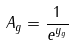<formula> <loc_0><loc_0><loc_500><loc_500>A _ { g } = \frac { 1 } { e ^ { y _ { g } } }</formula> 